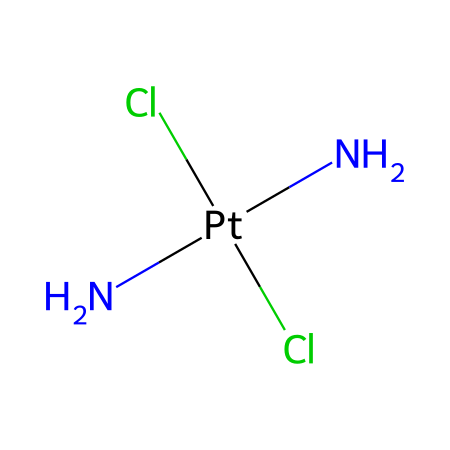What is the central metal ion in this coordination complex? The structure indicates that platinum (Pt) is the central ion since it is represented as being surrounded by coordinated ligands.
Answer: platinum How many chloride ligands are present in the structure? The SMILES representation includes two chlorine atoms (Cl) connected to the platinum center, indicating there are two chloride ligands.
Answer: two What is the coordination number of the central metal in this complex? The coordination number is determined by counting the total number of bonds to the central metal ion. In this case, there are four bonds (two to chloride and two to amine groups), suggesting a coordination number of four.
Answer: four Is the geometry of this coordination compound octahedral or square planar? Given the coordination number and the specific ligands present (two of which are identical and two are different), the geometry tends to be square planar, which is common for cisplatin and similar complexes.
Answer: square planar What type of ligands are present in this coordination complex? The ligands consist of amine (N) and chloride (Cl) ligands, with two of each type being present, indicating a mixture of neutral and anionic ligands.
Answer: amine and chloride What clinical application does this coordination compound have? This coordination compound is primarily known for its use as a chemotherapy drug to treat various forms of cancer, leveraging its ability to bind to DNA and interfere with cell division.
Answer: chemotherapy 